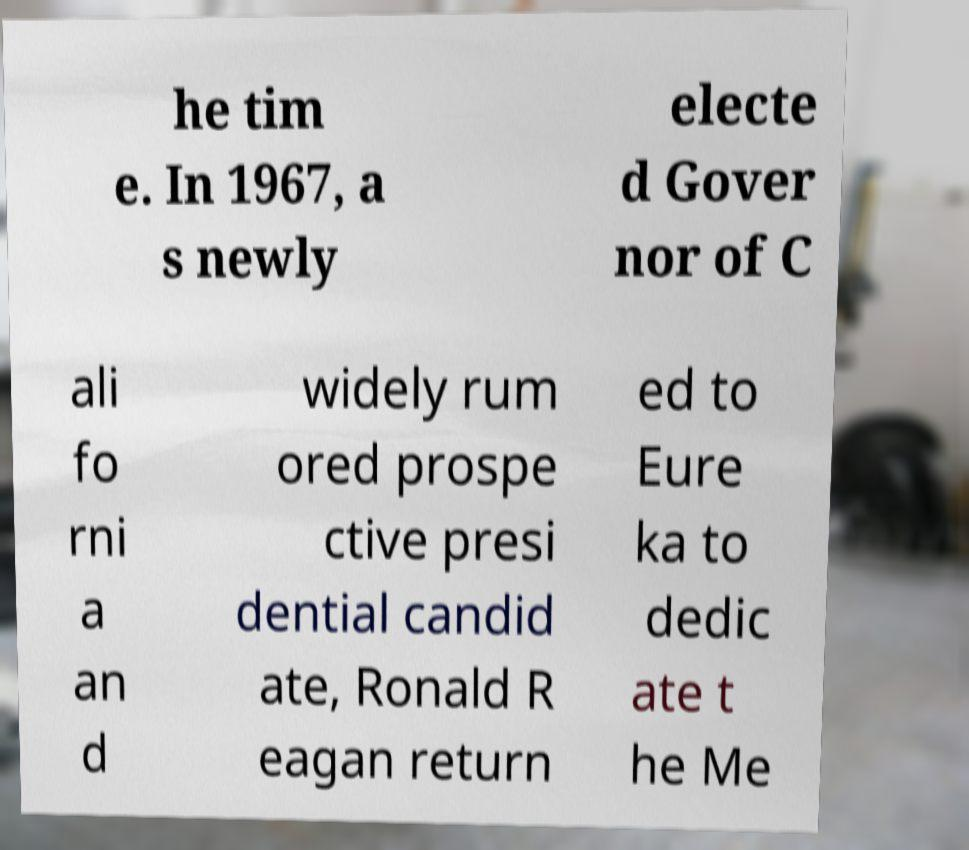What messages or text are displayed in this image? I need them in a readable, typed format. he tim e. In 1967, a s newly electe d Gover nor of C ali fo rni a an d widely rum ored prospe ctive presi dential candid ate, Ronald R eagan return ed to Eure ka to dedic ate t he Me 